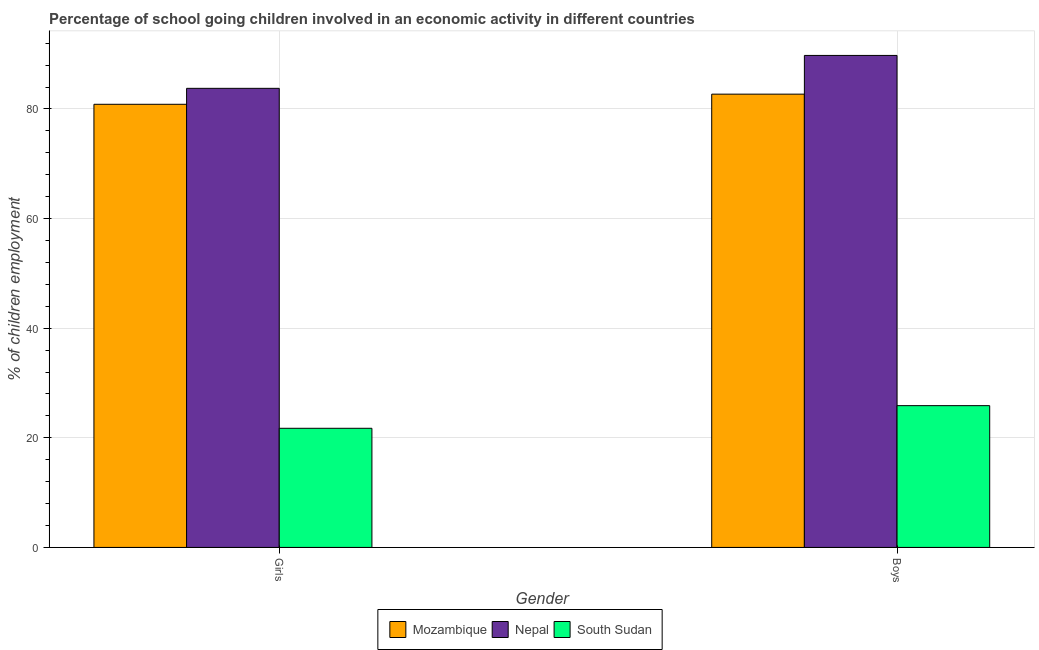How many groups of bars are there?
Offer a terse response. 2. Are the number of bars per tick equal to the number of legend labels?
Provide a succinct answer. Yes. How many bars are there on the 2nd tick from the left?
Offer a very short reply. 3. How many bars are there on the 1st tick from the right?
Provide a succinct answer. 3. What is the label of the 1st group of bars from the left?
Keep it short and to the point. Girls. What is the percentage of school going boys in Nepal?
Provide a succinct answer. 89.76. Across all countries, what is the maximum percentage of school going girls?
Give a very brief answer. 83.76. Across all countries, what is the minimum percentage of school going boys?
Make the answer very short. 25.87. In which country was the percentage of school going boys maximum?
Provide a short and direct response. Nepal. In which country was the percentage of school going boys minimum?
Make the answer very short. South Sudan. What is the total percentage of school going girls in the graph?
Your answer should be very brief. 186.35. What is the difference between the percentage of school going boys in Mozambique and that in South Sudan?
Ensure brevity in your answer.  56.83. What is the difference between the percentage of school going boys in Nepal and the percentage of school going girls in Mozambique?
Ensure brevity in your answer.  8.91. What is the average percentage of school going boys per country?
Make the answer very short. 66.11. What is the difference between the percentage of school going girls and percentage of school going boys in Mozambique?
Your answer should be very brief. -1.85. In how many countries, is the percentage of school going girls greater than 48 %?
Give a very brief answer. 2. What is the ratio of the percentage of school going girls in South Sudan to that in Mozambique?
Offer a very short reply. 0.27. Is the percentage of school going girls in Mozambique less than that in South Sudan?
Keep it short and to the point. No. In how many countries, is the percentage of school going girls greater than the average percentage of school going girls taken over all countries?
Give a very brief answer. 2. What does the 1st bar from the left in Girls represents?
Your answer should be very brief. Mozambique. What does the 2nd bar from the right in Girls represents?
Your response must be concise. Nepal. Are all the bars in the graph horizontal?
Offer a very short reply. No. Are the values on the major ticks of Y-axis written in scientific E-notation?
Make the answer very short. No. What is the title of the graph?
Give a very brief answer. Percentage of school going children involved in an economic activity in different countries. What is the label or title of the Y-axis?
Your answer should be very brief. % of children employment. What is the % of children employment in Mozambique in Girls?
Provide a short and direct response. 80.85. What is the % of children employment of Nepal in Girls?
Give a very brief answer. 83.76. What is the % of children employment of South Sudan in Girls?
Your answer should be compact. 21.74. What is the % of children employment in Mozambique in Boys?
Your answer should be very brief. 82.7. What is the % of children employment of Nepal in Boys?
Provide a succinct answer. 89.76. What is the % of children employment of South Sudan in Boys?
Provide a succinct answer. 25.87. Across all Gender, what is the maximum % of children employment of Mozambique?
Provide a succinct answer. 82.7. Across all Gender, what is the maximum % of children employment in Nepal?
Give a very brief answer. 89.76. Across all Gender, what is the maximum % of children employment in South Sudan?
Provide a succinct answer. 25.87. Across all Gender, what is the minimum % of children employment of Mozambique?
Your response must be concise. 80.85. Across all Gender, what is the minimum % of children employment in Nepal?
Your response must be concise. 83.76. Across all Gender, what is the minimum % of children employment in South Sudan?
Offer a terse response. 21.74. What is the total % of children employment in Mozambique in the graph?
Offer a very short reply. 163.55. What is the total % of children employment in Nepal in the graph?
Offer a very short reply. 173.52. What is the total % of children employment of South Sudan in the graph?
Offer a very short reply. 47.6. What is the difference between the % of children employment of Mozambique in Girls and that in Boys?
Your answer should be very brief. -1.85. What is the difference between the % of children employment of Nepal in Girls and that in Boys?
Ensure brevity in your answer.  -6. What is the difference between the % of children employment in South Sudan in Girls and that in Boys?
Keep it short and to the point. -4.13. What is the difference between the % of children employment in Mozambique in Girls and the % of children employment in Nepal in Boys?
Offer a terse response. -8.91. What is the difference between the % of children employment in Mozambique in Girls and the % of children employment in South Sudan in Boys?
Ensure brevity in your answer.  54.98. What is the difference between the % of children employment in Nepal in Girls and the % of children employment in South Sudan in Boys?
Your response must be concise. 57.89. What is the average % of children employment of Mozambique per Gender?
Your response must be concise. 81.77. What is the average % of children employment in Nepal per Gender?
Offer a terse response. 86.76. What is the average % of children employment in South Sudan per Gender?
Provide a succinct answer. 23.8. What is the difference between the % of children employment in Mozambique and % of children employment in Nepal in Girls?
Ensure brevity in your answer.  -2.91. What is the difference between the % of children employment in Mozambique and % of children employment in South Sudan in Girls?
Offer a very short reply. 59.11. What is the difference between the % of children employment in Nepal and % of children employment in South Sudan in Girls?
Ensure brevity in your answer.  62.02. What is the difference between the % of children employment of Mozambique and % of children employment of Nepal in Boys?
Your answer should be compact. -7.07. What is the difference between the % of children employment in Mozambique and % of children employment in South Sudan in Boys?
Offer a terse response. 56.83. What is the difference between the % of children employment in Nepal and % of children employment in South Sudan in Boys?
Provide a short and direct response. 63.9. What is the ratio of the % of children employment in Mozambique in Girls to that in Boys?
Give a very brief answer. 0.98. What is the ratio of the % of children employment in Nepal in Girls to that in Boys?
Your answer should be very brief. 0.93. What is the ratio of the % of children employment in South Sudan in Girls to that in Boys?
Give a very brief answer. 0.84. What is the difference between the highest and the second highest % of children employment of Mozambique?
Your answer should be very brief. 1.85. What is the difference between the highest and the second highest % of children employment in Nepal?
Give a very brief answer. 6. What is the difference between the highest and the second highest % of children employment of South Sudan?
Make the answer very short. 4.13. What is the difference between the highest and the lowest % of children employment in Mozambique?
Ensure brevity in your answer.  1.85. What is the difference between the highest and the lowest % of children employment of Nepal?
Provide a short and direct response. 6. What is the difference between the highest and the lowest % of children employment in South Sudan?
Give a very brief answer. 4.13. 